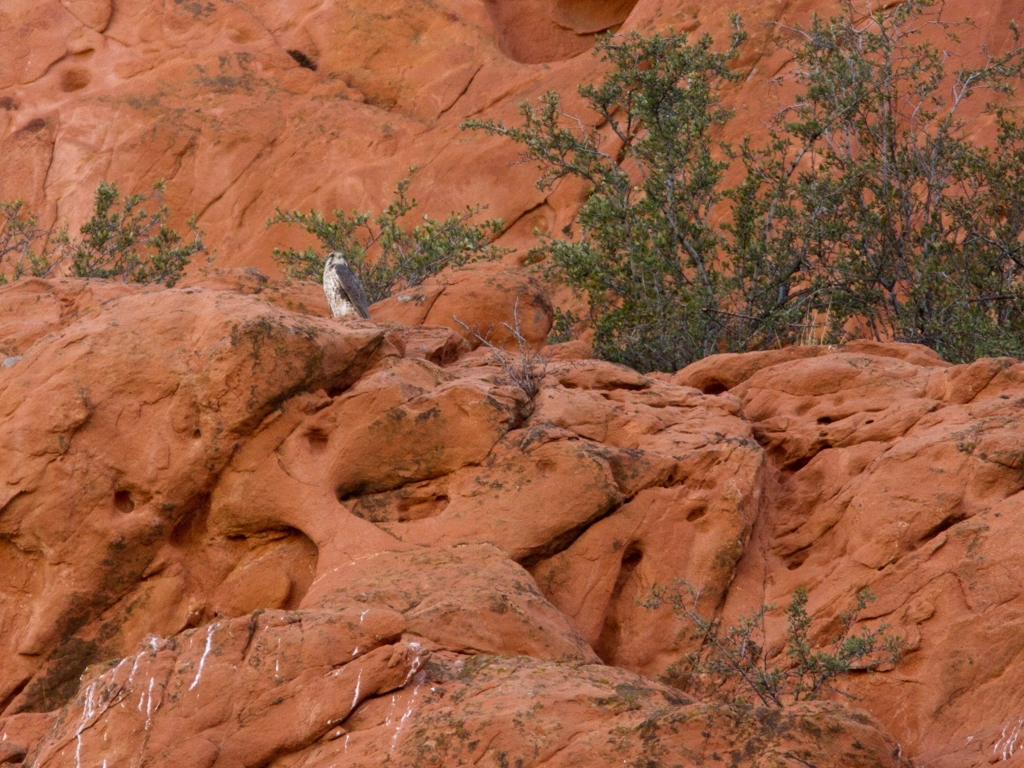What kind of weather conditions does this image suggest about the region? The overcast sky implies that the region may experience variable weather conditions. The dry, rocky landscape suggests an arid climate with infrequent precipitation. These conditions are typical of desert or semi-desert regions, where rain can be scarce but cloud cover might occasionally offer respite from the sun. 